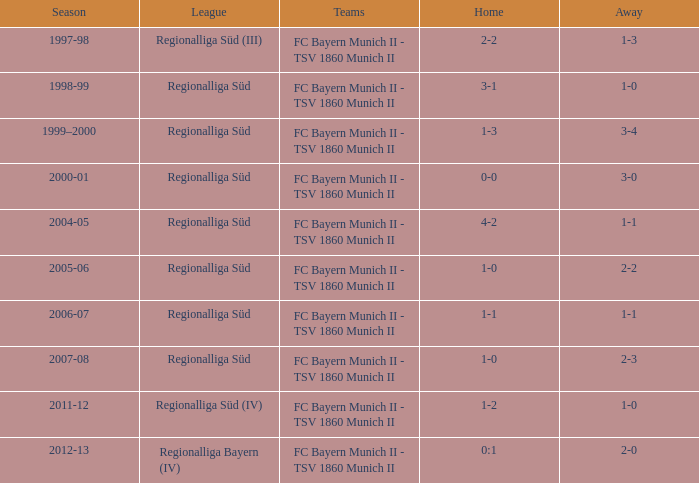Which teams took part in the 2006-07 season? FC Bayern Munich II - TSV 1860 Munich II. 